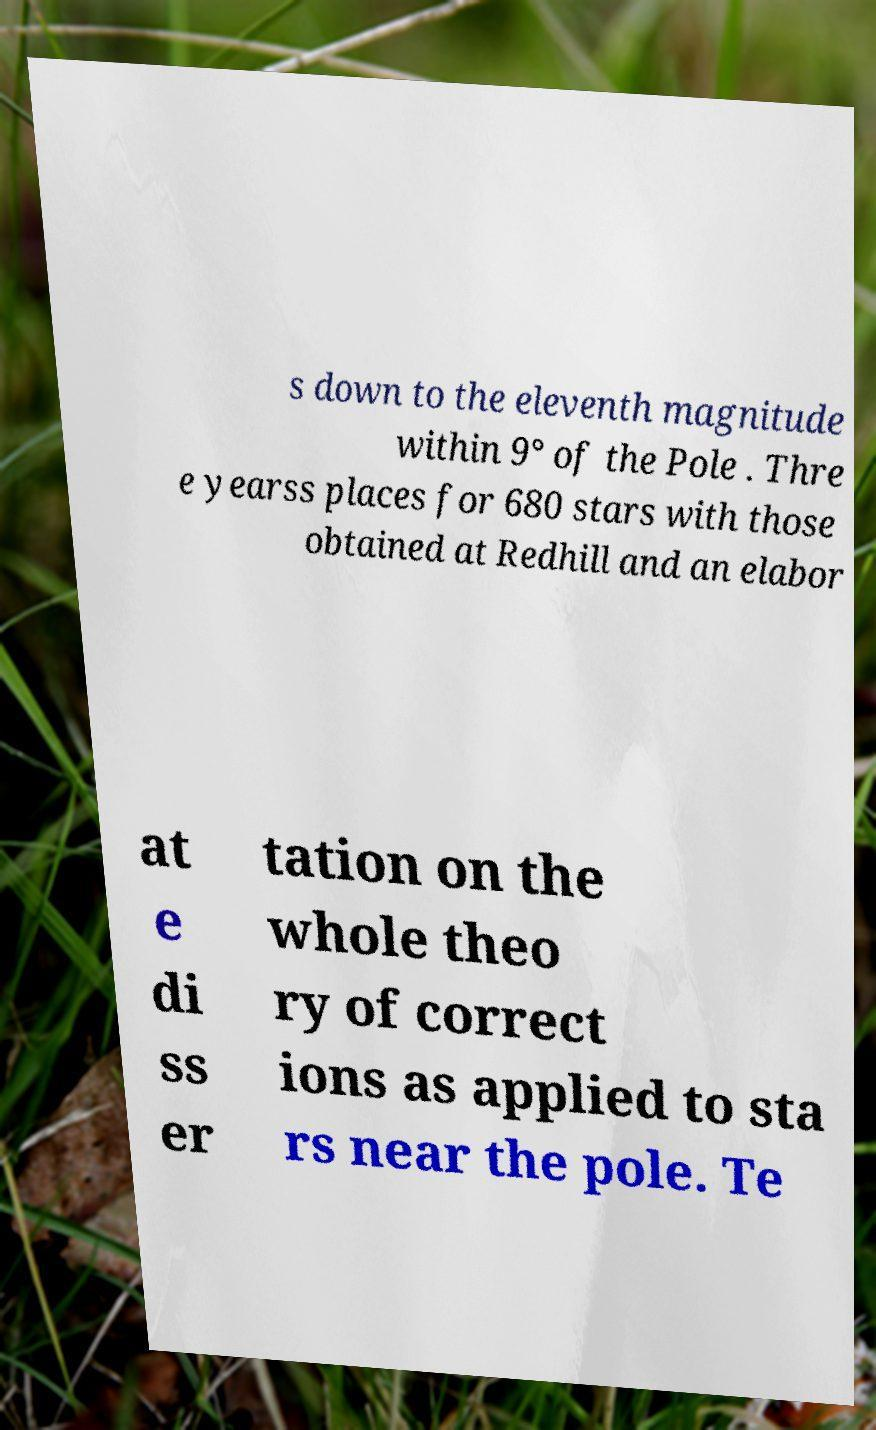Please read and relay the text visible in this image. What does it say? s down to the eleventh magnitude within 9° of the Pole . Thre e yearss places for 680 stars with those obtained at Redhill and an elabor at e di ss er tation on the whole theo ry of correct ions as applied to sta rs near the pole. Te 